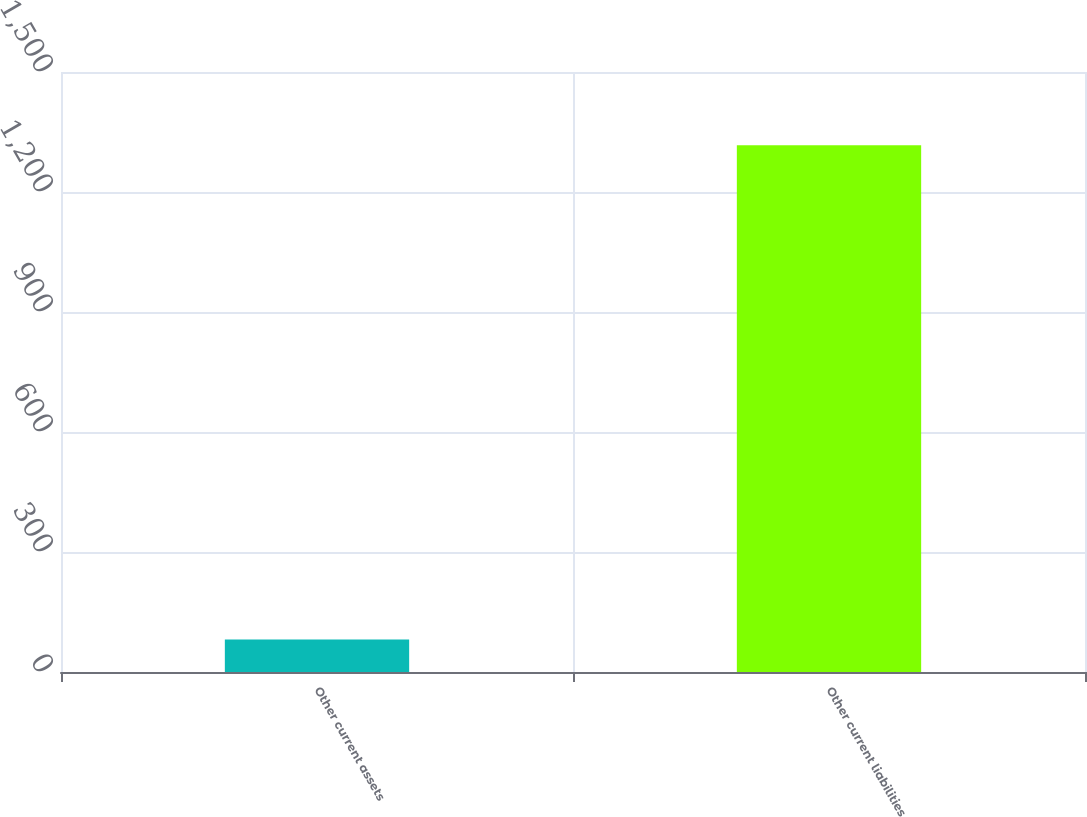<chart> <loc_0><loc_0><loc_500><loc_500><bar_chart><fcel>Other current assets<fcel>Other current liabilities<nl><fcel>81<fcel>1317<nl></chart> 